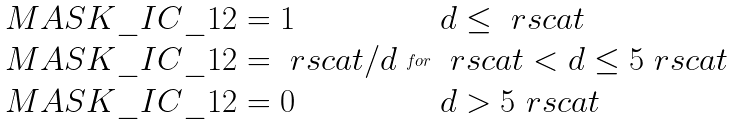Convert formula to latex. <formula><loc_0><loc_0><loc_500><loc_500>\begin{array} { l } { M A S K \_ I C \_ 1 2 } = 1 \\ { M A S K \_ I C \_ 1 2 } = \ r s c a t / d \\ { M A S K \_ I C \_ 1 2 } = 0 \end{array} f o r \begin{array} { l } d \leq \ r s c a t \\ \ r s c a t < d \leq 5 \ r s c a t \\ d > 5 \ r s c a t \end{array}</formula> 